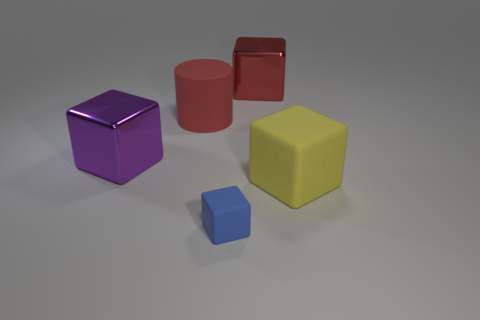There is a purple block that is the same size as the rubber cylinder; what material is it?
Provide a short and direct response. Metal. Are the object that is in front of the large yellow rubber object and the red block that is behind the small rubber object made of the same material?
Give a very brief answer. No. What shape is the yellow object that is the same size as the purple object?
Offer a terse response. Cube. How many other things are the same color as the small rubber block?
Provide a short and direct response. 0. There is a big metallic block on the left side of the small blue matte block; what is its color?
Give a very brief answer. Purple. How many other things are there of the same material as the purple thing?
Your answer should be compact. 1. Is the number of red matte cylinders to the right of the matte cylinder greater than the number of matte objects in front of the tiny blue thing?
Your answer should be very brief. No. What number of red blocks are in front of the yellow thing?
Provide a succinct answer. 0. Is the material of the tiny cube the same as the yellow block on the right side of the large cylinder?
Make the answer very short. Yes. Is there anything else that has the same shape as the red rubber object?
Offer a terse response. No. 